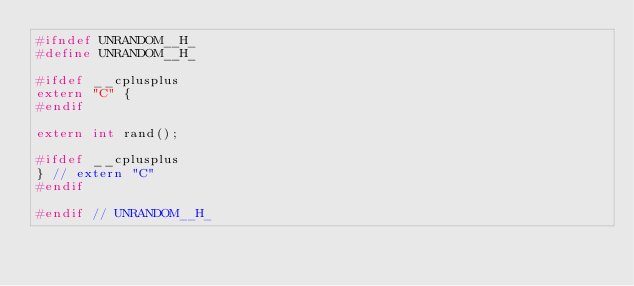Convert code to text. <code><loc_0><loc_0><loc_500><loc_500><_C_>#ifndef UNRANDOM__H_
#define UNRANDOM__H_

#ifdef __cplusplus
extern "C" {
#endif

extern int rand();

#ifdef __cplusplus
} // extern "C"
#endif

#endif // UNRANDOM__H_
</code> 